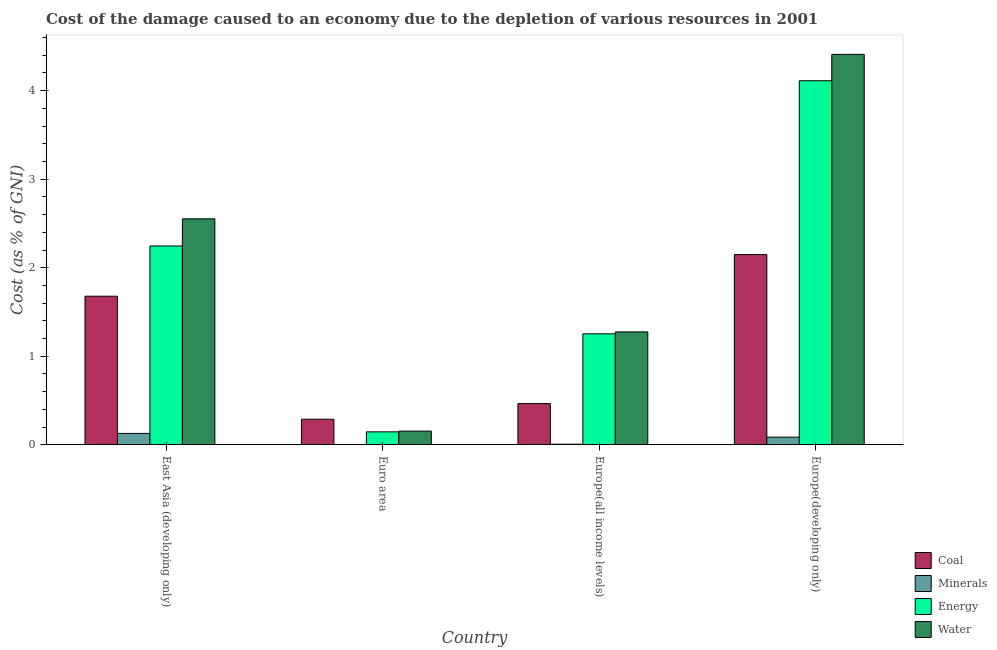How many groups of bars are there?
Offer a very short reply. 4. Are the number of bars on each tick of the X-axis equal?
Provide a short and direct response. Yes. How many bars are there on the 4th tick from the left?
Give a very brief answer. 4. How many bars are there on the 3rd tick from the right?
Your answer should be very brief. 4. What is the label of the 4th group of bars from the left?
Keep it short and to the point. Europe(developing only). What is the cost of damage due to depletion of energy in Euro area?
Give a very brief answer. 0.15. Across all countries, what is the maximum cost of damage due to depletion of water?
Ensure brevity in your answer.  4.41. Across all countries, what is the minimum cost of damage due to depletion of water?
Offer a very short reply. 0.15. In which country was the cost of damage due to depletion of coal maximum?
Offer a very short reply. Europe(developing only). In which country was the cost of damage due to depletion of coal minimum?
Provide a succinct answer. Euro area. What is the total cost of damage due to depletion of water in the graph?
Ensure brevity in your answer.  8.39. What is the difference between the cost of damage due to depletion of water in East Asia (developing only) and that in Europe(developing only)?
Your response must be concise. -1.86. What is the difference between the cost of damage due to depletion of coal in Europe(all income levels) and the cost of damage due to depletion of minerals in Europe(developing only)?
Provide a succinct answer. 0.38. What is the average cost of damage due to depletion of energy per country?
Provide a succinct answer. 1.94. What is the difference between the cost of damage due to depletion of water and cost of damage due to depletion of coal in Europe(all income levels)?
Offer a terse response. 0.81. What is the ratio of the cost of damage due to depletion of water in Europe(all income levels) to that in Europe(developing only)?
Make the answer very short. 0.29. What is the difference between the highest and the second highest cost of damage due to depletion of coal?
Make the answer very short. 0.47. What is the difference between the highest and the lowest cost of damage due to depletion of coal?
Your answer should be compact. 1.86. Is it the case that in every country, the sum of the cost of damage due to depletion of coal and cost of damage due to depletion of minerals is greater than the sum of cost of damage due to depletion of energy and cost of damage due to depletion of water?
Keep it short and to the point. No. What does the 2nd bar from the left in Europe(developing only) represents?
Your response must be concise. Minerals. What does the 1st bar from the right in Europe(developing only) represents?
Your answer should be compact. Water. Is it the case that in every country, the sum of the cost of damage due to depletion of coal and cost of damage due to depletion of minerals is greater than the cost of damage due to depletion of energy?
Offer a very short reply. No. Are all the bars in the graph horizontal?
Give a very brief answer. No. What is the difference between two consecutive major ticks on the Y-axis?
Keep it short and to the point. 1. Are the values on the major ticks of Y-axis written in scientific E-notation?
Your answer should be compact. No. Does the graph contain grids?
Offer a very short reply. No. Where does the legend appear in the graph?
Provide a succinct answer. Bottom right. How are the legend labels stacked?
Give a very brief answer. Vertical. What is the title of the graph?
Your answer should be very brief. Cost of the damage caused to an economy due to the depletion of various resources in 2001 . Does "European Union" appear as one of the legend labels in the graph?
Give a very brief answer. No. What is the label or title of the Y-axis?
Your answer should be very brief. Cost (as % of GNI). What is the Cost (as % of GNI) in Coal in East Asia (developing only)?
Keep it short and to the point. 1.68. What is the Cost (as % of GNI) in Minerals in East Asia (developing only)?
Your answer should be very brief. 0.13. What is the Cost (as % of GNI) of Energy in East Asia (developing only)?
Your answer should be compact. 2.25. What is the Cost (as % of GNI) of Water in East Asia (developing only)?
Your answer should be very brief. 2.55. What is the Cost (as % of GNI) in Coal in Euro area?
Keep it short and to the point. 0.29. What is the Cost (as % of GNI) in Minerals in Euro area?
Provide a succinct answer. 0. What is the Cost (as % of GNI) of Energy in Euro area?
Give a very brief answer. 0.15. What is the Cost (as % of GNI) of Water in Euro area?
Make the answer very short. 0.15. What is the Cost (as % of GNI) in Coal in Europe(all income levels)?
Your response must be concise. 0.47. What is the Cost (as % of GNI) of Minerals in Europe(all income levels)?
Your response must be concise. 0.01. What is the Cost (as % of GNI) in Energy in Europe(all income levels)?
Your answer should be compact. 1.25. What is the Cost (as % of GNI) in Water in Europe(all income levels)?
Provide a succinct answer. 1.28. What is the Cost (as % of GNI) of Coal in Europe(developing only)?
Offer a very short reply. 2.15. What is the Cost (as % of GNI) in Minerals in Europe(developing only)?
Your answer should be very brief. 0.09. What is the Cost (as % of GNI) in Energy in Europe(developing only)?
Make the answer very short. 4.11. What is the Cost (as % of GNI) in Water in Europe(developing only)?
Offer a very short reply. 4.41. Across all countries, what is the maximum Cost (as % of GNI) in Coal?
Ensure brevity in your answer.  2.15. Across all countries, what is the maximum Cost (as % of GNI) of Minerals?
Provide a succinct answer. 0.13. Across all countries, what is the maximum Cost (as % of GNI) of Energy?
Ensure brevity in your answer.  4.11. Across all countries, what is the maximum Cost (as % of GNI) of Water?
Keep it short and to the point. 4.41. Across all countries, what is the minimum Cost (as % of GNI) in Coal?
Provide a succinct answer. 0.29. Across all countries, what is the minimum Cost (as % of GNI) in Minerals?
Make the answer very short. 0. Across all countries, what is the minimum Cost (as % of GNI) of Energy?
Make the answer very short. 0.15. Across all countries, what is the minimum Cost (as % of GNI) in Water?
Provide a succinct answer. 0.15. What is the total Cost (as % of GNI) of Coal in the graph?
Give a very brief answer. 4.58. What is the total Cost (as % of GNI) of Minerals in the graph?
Make the answer very short. 0.22. What is the total Cost (as % of GNI) of Energy in the graph?
Your response must be concise. 7.76. What is the total Cost (as % of GNI) of Water in the graph?
Your answer should be very brief. 8.39. What is the difference between the Cost (as % of GNI) in Coal in East Asia (developing only) and that in Euro area?
Make the answer very short. 1.39. What is the difference between the Cost (as % of GNI) in Minerals in East Asia (developing only) and that in Euro area?
Keep it short and to the point. 0.13. What is the difference between the Cost (as % of GNI) in Energy in East Asia (developing only) and that in Euro area?
Make the answer very short. 2.1. What is the difference between the Cost (as % of GNI) in Water in East Asia (developing only) and that in Euro area?
Your response must be concise. 2.4. What is the difference between the Cost (as % of GNI) of Coal in East Asia (developing only) and that in Europe(all income levels)?
Ensure brevity in your answer.  1.21. What is the difference between the Cost (as % of GNI) of Minerals in East Asia (developing only) and that in Europe(all income levels)?
Provide a succinct answer. 0.12. What is the difference between the Cost (as % of GNI) of Water in East Asia (developing only) and that in Europe(all income levels)?
Keep it short and to the point. 1.28. What is the difference between the Cost (as % of GNI) of Coal in East Asia (developing only) and that in Europe(developing only)?
Give a very brief answer. -0.47. What is the difference between the Cost (as % of GNI) of Minerals in East Asia (developing only) and that in Europe(developing only)?
Provide a short and direct response. 0.04. What is the difference between the Cost (as % of GNI) of Energy in East Asia (developing only) and that in Europe(developing only)?
Offer a terse response. -1.87. What is the difference between the Cost (as % of GNI) of Water in East Asia (developing only) and that in Europe(developing only)?
Keep it short and to the point. -1.86. What is the difference between the Cost (as % of GNI) of Coal in Euro area and that in Europe(all income levels)?
Give a very brief answer. -0.18. What is the difference between the Cost (as % of GNI) of Minerals in Euro area and that in Europe(all income levels)?
Keep it short and to the point. -0.01. What is the difference between the Cost (as % of GNI) of Energy in Euro area and that in Europe(all income levels)?
Provide a short and direct response. -1.11. What is the difference between the Cost (as % of GNI) in Water in Euro area and that in Europe(all income levels)?
Offer a very short reply. -1.12. What is the difference between the Cost (as % of GNI) in Coal in Euro area and that in Europe(developing only)?
Make the answer very short. -1.86. What is the difference between the Cost (as % of GNI) of Minerals in Euro area and that in Europe(developing only)?
Your answer should be compact. -0.09. What is the difference between the Cost (as % of GNI) in Energy in Euro area and that in Europe(developing only)?
Your answer should be very brief. -3.97. What is the difference between the Cost (as % of GNI) of Water in Euro area and that in Europe(developing only)?
Offer a very short reply. -4.26. What is the difference between the Cost (as % of GNI) of Coal in Europe(all income levels) and that in Europe(developing only)?
Your response must be concise. -1.68. What is the difference between the Cost (as % of GNI) in Minerals in Europe(all income levels) and that in Europe(developing only)?
Make the answer very short. -0.08. What is the difference between the Cost (as % of GNI) of Energy in Europe(all income levels) and that in Europe(developing only)?
Give a very brief answer. -2.86. What is the difference between the Cost (as % of GNI) of Water in Europe(all income levels) and that in Europe(developing only)?
Your answer should be compact. -3.13. What is the difference between the Cost (as % of GNI) of Coal in East Asia (developing only) and the Cost (as % of GNI) of Minerals in Euro area?
Ensure brevity in your answer.  1.68. What is the difference between the Cost (as % of GNI) of Coal in East Asia (developing only) and the Cost (as % of GNI) of Energy in Euro area?
Make the answer very short. 1.53. What is the difference between the Cost (as % of GNI) of Coal in East Asia (developing only) and the Cost (as % of GNI) of Water in Euro area?
Offer a very short reply. 1.52. What is the difference between the Cost (as % of GNI) of Minerals in East Asia (developing only) and the Cost (as % of GNI) of Energy in Euro area?
Your answer should be very brief. -0.02. What is the difference between the Cost (as % of GNI) of Minerals in East Asia (developing only) and the Cost (as % of GNI) of Water in Euro area?
Provide a succinct answer. -0.03. What is the difference between the Cost (as % of GNI) of Energy in East Asia (developing only) and the Cost (as % of GNI) of Water in Euro area?
Give a very brief answer. 2.09. What is the difference between the Cost (as % of GNI) in Coal in East Asia (developing only) and the Cost (as % of GNI) in Minerals in Europe(all income levels)?
Your response must be concise. 1.67. What is the difference between the Cost (as % of GNI) of Coal in East Asia (developing only) and the Cost (as % of GNI) of Energy in Europe(all income levels)?
Your answer should be very brief. 0.42. What is the difference between the Cost (as % of GNI) in Coal in East Asia (developing only) and the Cost (as % of GNI) in Water in Europe(all income levels)?
Your response must be concise. 0.4. What is the difference between the Cost (as % of GNI) of Minerals in East Asia (developing only) and the Cost (as % of GNI) of Energy in Europe(all income levels)?
Offer a terse response. -1.12. What is the difference between the Cost (as % of GNI) of Minerals in East Asia (developing only) and the Cost (as % of GNI) of Water in Europe(all income levels)?
Offer a very short reply. -1.15. What is the difference between the Cost (as % of GNI) of Energy in East Asia (developing only) and the Cost (as % of GNI) of Water in Europe(all income levels)?
Provide a succinct answer. 0.97. What is the difference between the Cost (as % of GNI) of Coal in East Asia (developing only) and the Cost (as % of GNI) of Minerals in Europe(developing only)?
Offer a very short reply. 1.59. What is the difference between the Cost (as % of GNI) of Coal in East Asia (developing only) and the Cost (as % of GNI) of Energy in Europe(developing only)?
Offer a terse response. -2.43. What is the difference between the Cost (as % of GNI) in Coal in East Asia (developing only) and the Cost (as % of GNI) in Water in Europe(developing only)?
Provide a succinct answer. -2.73. What is the difference between the Cost (as % of GNI) of Minerals in East Asia (developing only) and the Cost (as % of GNI) of Energy in Europe(developing only)?
Give a very brief answer. -3.98. What is the difference between the Cost (as % of GNI) in Minerals in East Asia (developing only) and the Cost (as % of GNI) in Water in Europe(developing only)?
Offer a very short reply. -4.28. What is the difference between the Cost (as % of GNI) in Energy in East Asia (developing only) and the Cost (as % of GNI) in Water in Europe(developing only)?
Provide a short and direct response. -2.16. What is the difference between the Cost (as % of GNI) of Coal in Euro area and the Cost (as % of GNI) of Minerals in Europe(all income levels)?
Your response must be concise. 0.28. What is the difference between the Cost (as % of GNI) in Coal in Euro area and the Cost (as % of GNI) in Energy in Europe(all income levels)?
Offer a very short reply. -0.96. What is the difference between the Cost (as % of GNI) in Coal in Euro area and the Cost (as % of GNI) in Water in Europe(all income levels)?
Offer a very short reply. -0.99. What is the difference between the Cost (as % of GNI) in Minerals in Euro area and the Cost (as % of GNI) in Energy in Europe(all income levels)?
Give a very brief answer. -1.25. What is the difference between the Cost (as % of GNI) of Minerals in Euro area and the Cost (as % of GNI) of Water in Europe(all income levels)?
Your response must be concise. -1.27. What is the difference between the Cost (as % of GNI) of Energy in Euro area and the Cost (as % of GNI) of Water in Europe(all income levels)?
Ensure brevity in your answer.  -1.13. What is the difference between the Cost (as % of GNI) of Coal in Euro area and the Cost (as % of GNI) of Minerals in Europe(developing only)?
Make the answer very short. 0.2. What is the difference between the Cost (as % of GNI) in Coal in Euro area and the Cost (as % of GNI) in Energy in Europe(developing only)?
Provide a succinct answer. -3.82. What is the difference between the Cost (as % of GNI) in Coal in Euro area and the Cost (as % of GNI) in Water in Europe(developing only)?
Your answer should be compact. -4.12. What is the difference between the Cost (as % of GNI) in Minerals in Euro area and the Cost (as % of GNI) in Energy in Europe(developing only)?
Ensure brevity in your answer.  -4.11. What is the difference between the Cost (as % of GNI) in Minerals in Euro area and the Cost (as % of GNI) in Water in Europe(developing only)?
Ensure brevity in your answer.  -4.41. What is the difference between the Cost (as % of GNI) in Energy in Euro area and the Cost (as % of GNI) in Water in Europe(developing only)?
Provide a short and direct response. -4.26. What is the difference between the Cost (as % of GNI) of Coal in Europe(all income levels) and the Cost (as % of GNI) of Minerals in Europe(developing only)?
Offer a very short reply. 0.38. What is the difference between the Cost (as % of GNI) in Coal in Europe(all income levels) and the Cost (as % of GNI) in Energy in Europe(developing only)?
Your answer should be compact. -3.65. What is the difference between the Cost (as % of GNI) of Coal in Europe(all income levels) and the Cost (as % of GNI) of Water in Europe(developing only)?
Your answer should be compact. -3.94. What is the difference between the Cost (as % of GNI) in Minerals in Europe(all income levels) and the Cost (as % of GNI) in Energy in Europe(developing only)?
Ensure brevity in your answer.  -4.11. What is the difference between the Cost (as % of GNI) in Minerals in Europe(all income levels) and the Cost (as % of GNI) in Water in Europe(developing only)?
Your answer should be compact. -4.4. What is the difference between the Cost (as % of GNI) in Energy in Europe(all income levels) and the Cost (as % of GNI) in Water in Europe(developing only)?
Keep it short and to the point. -3.16. What is the average Cost (as % of GNI) in Coal per country?
Provide a short and direct response. 1.15. What is the average Cost (as % of GNI) of Minerals per country?
Offer a terse response. 0.06. What is the average Cost (as % of GNI) in Energy per country?
Provide a short and direct response. 1.94. What is the average Cost (as % of GNI) of Water per country?
Your answer should be compact. 2.1. What is the difference between the Cost (as % of GNI) in Coal and Cost (as % of GNI) in Minerals in East Asia (developing only)?
Your answer should be compact. 1.55. What is the difference between the Cost (as % of GNI) in Coal and Cost (as % of GNI) in Energy in East Asia (developing only)?
Your response must be concise. -0.57. What is the difference between the Cost (as % of GNI) of Coal and Cost (as % of GNI) of Water in East Asia (developing only)?
Offer a very short reply. -0.87. What is the difference between the Cost (as % of GNI) of Minerals and Cost (as % of GNI) of Energy in East Asia (developing only)?
Ensure brevity in your answer.  -2.12. What is the difference between the Cost (as % of GNI) in Minerals and Cost (as % of GNI) in Water in East Asia (developing only)?
Offer a very short reply. -2.42. What is the difference between the Cost (as % of GNI) in Energy and Cost (as % of GNI) in Water in East Asia (developing only)?
Provide a succinct answer. -0.31. What is the difference between the Cost (as % of GNI) in Coal and Cost (as % of GNI) in Minerals in Euro area?
Your answer should be compact. 0.29. What is the difference between the Cost (as % of GNI) in Coal and Cost (as % of GNI) in Energy in Euro area?
Make the answer very short. 0.14. What is the difference between the Cost (as % of GNI) of Coal and Cost (as % of GNI) of Water in Euro area?
Provide a succinct answer. 0.13. What is the difference between the Cost (as % of GNI) of Minerals and Cost (as % of GNI) of Energy in Euro area?
Your answer should be compact. -0.15. What is the difference between the Cost (as % of GNI) of Minerals and Cost (as % of GNI) of Water in Euro area?
Ensure brevity in your answer.  -0.15. What is the difference between the Cost (as % of GNI) in Energy and Cost (as % of GNI) in Water in Euro area?
Provide a succinct answer. -0.01. What is the difference between the Cost (as % of GNI) in Coal and Cost (as % of GNI) in Minerals in Europe(all income levels)?
Keep it short and to the point. 0.46. What is the difference between the Cost (as % of GNI) in Coal and Cost (as % of GNI) in Energy in Europe(all income levels)?
Give a very brief answer. -0.79. What is the difference between the Cost (as % of GNI) in Coal and Cost (as % of GNI) in Water in Europe(all income levels)?
Give a very brief answer. -0.81. What is the difference between the Cost (as % of GNI) of Minerals and Cost (as % of GNI) of Energy in Europe(all income levels)?
Your response must be concise. -1.25. What is the difference between the Cost (as % of GNI) of Minerals and Cost (as % of GNI) of Water in Europe(all income levels)?
Ensure brevity in your answer.  -1.27. What is the difference between the Cost (as % of GNI) in Energy and Cost (as % of GNI) in Water in Europe(all income levels)?
Make the answer very short. -0.02. What is the difference between the Cost (as % of GNI) in Coal and Cost (as % of GNI) in Minerals in Europe(developing only)?
Provide a succinct answer. 2.06. What is the difference between the Cost (as % of GNI) in Coal and Cost (as % of GNI) in Energy in Europe(developing only)?
Keep it short and to the point. -1.96. What is the difference between the Cost (as % of GNI) of Coal and Cost (as % of GNI) of Water in Europe(developing only)?
Provide a succinct answer. -2.26. What is the difference between the Cost (as % of GNI) in Minerals and Cost (as % of GNI) in Energy in Europe(developing only)?
Make the answer very short. -4.03. What is the difference between the Cost (as % of GNI) in Minerals and Cost (as % of GNI) in Water in Europe(developing only)?
Give a very brief answer. -4.32. What is the difference between the Cost (as % of GNI) of Energy and Cost (as % of GNI) of Water in Europe(developing only)?
Provide a succinct answer. -0.3. What is the ratio of the Cost (as % of GNI) in Coal in East Asia (developing only) to that in Euro area?
Give a very brief answer. 5.81. What is the ratio of the Cost (as % of GNI) of Minerals in East Asia (developing only) to that in Euro area?
Provide a short and direct response. 739.7. What is the ratio of the Cost (as % of GNI) of Energy in East Asia (developing only) to that in Euro area?
Make the answer very short. 15.35. What is the ratio of the Cost (as % of GNI) in Water in East Asia (developing only) to that in Euro area?
Offer a very short reply. 16.51. What is the ratio of the Cost (as % of GNI) of Coal in East Asia (developing only) to that in Europe(all income levels)?
Keep it short and to the point. 3.61. What is the ratio of the Cost (as % of GNI) in Minerals in East Asia (developing only) to that in Europe(all income levels)?
Make the answer very short. 19.65. What is the ratio of the Cost (as % of GNI) of Energy in East Asia (developing only) to that in Europe(all income levels)?
Give a very brief answer. 1.79. What is the ratio of the Cost (as % of GNI) in Water in East Asia (developing only) to that in Europe(all income levels)?
Offer a very short reply. 2. What is the ratio of the Cost (as % of GNI) in Coal in East Asia (developing only) to that in Europe(developing only)?
Ensure brevity in your answer.  0.78. What is the ratio of the Cost (as % of GNI) of Minerals in East Asia (developing only) to that in Europe(developing only)?
Your response must be concise. 1.49. What is the ratio of the Cost (as % of GNI) in Energy in East Asia (developing only) to that in Europe(developing only)?
Ensure brevity in your answer.  0.55. What is the ratio of the Cost (as % of GNI) in Water in East Asia (developing only) to that in Europe(developing only)?
Make the answer very short. 0.58. What is the ratio of the Cost (as % of GNI) in Coal in Euro area to that in Europe(all income levels)?
Your response must be concise. 0.62. What is the ratio of the Cost (as % of GNI) of Minerals in Euro area to that in Europe(all income levels)?
Offer a very short reply. 0.03. What is the ratio of the Cost (as % of GNI) of Energy in Euro area to that in Europe(all income levels)?
Provide a short and direct response. 0.12. What is the ratio of the Cost (as % of GNI) of Water in Euro area to that in Europe(all income levels)?
Ensure brevity in your answer.  0.12. What is the ratio of the Cost (as % of GNI) of Coal in Euro area to that in Europe(developing only)?
Your answer should be very brief. 0.13. What is the ratio of the Cost (as % of GNI) of Minerals in Euro area to that in Europe(developing only)?
Make the answer very short. 0. What is the ratio of the Cost (as % of GNI) of Energy in Euro area to that in Europe(developing only)?
Provide a short and direct response. 0.04. What is the ratio of the Cost (as % of GNI) in Water in Euro area to that in Europe(developing only)?
Keep it short and to the point. 0.04. What is the ratio of the Cost (as % of GNI) in Coal in Europe(all income levels) to that in Europe(developing only)?
Ensure brevity in your answer.  0.22. What is the ratio of the Cost (as % of GNI) in Minerals in Europe(all income levels) to that in Europe(developing only)?
Provide a short and direct response. 0.08. What is the ratio of the Cost (as % of GNI) in Energy in Europe(all income levels) to that in Europe(developing only)?
Your response must be concise. 0.3. What is the ratio of the Cost (as % of GNI) in Water in Europe(all income levels) to that in Europe(developing only)?
Ensure brevity in your answer.  0.29. What is the difference between the highest and the second highest Cost (as % of GNI) of Coal?
Ensure brevity in your answer.  0.47. What is the difference between the highest and the second highest Cost (as % of GNI) in Minerals?
Provide a succinct answer. 0.04. What is the difference between the highest and the second highest Cost (as % of GNI) in Energy?
Your answer should be compact. 1.87. What is the difference between the highest and the second highest Cost (as % of GNI) in Water?
Ensure brevity in your answer.  1.86. What is the difference between the highest and the lowest Cost (as % of GNI) of Coal?
Your answer should be compact. 1.86. What is the difference between the highest and the lowest Cost (as % of GNI) in Minerals?
Offer a very short reply. 0.13. What is the difference between the highest and the lowest Cost (as % of GNI) in Energy?
Your response must be concise. 3.97. What is the difference between the highest and the lowest Cost (as % of GNI) in Water?
Your answer should be very brief. 4.26. 